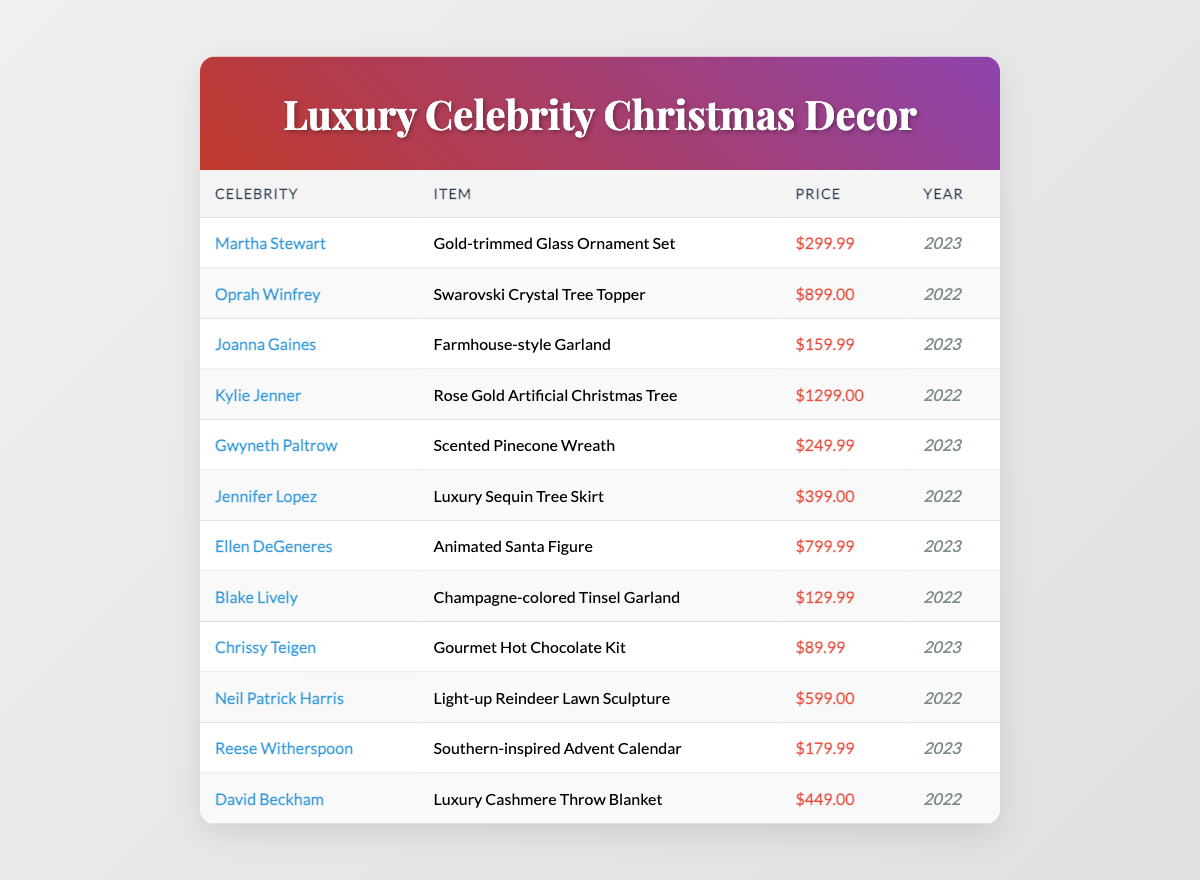What is the most expensive item in the list? To find the most expensive item, look at the price column and identify the highest value. The Rose Gold Artificial Christmas Tree by Kylie Jenner is priced at $1299.00, which is the highest among the items listed.
Answer: $1299.00 Which celebrity endorsed the Luxury Cashmere Throw Blanket? The table shows that the Luxury Cashmere Throw Blanket is endorsed by David Beckham. You can find his name in the celebrity column next to the corresponding item.
Answer: David Beckham How many items are there from the year 2023? Check the year column and count the occurrences of 2023. There are six items listed for the year 2023: Gold-trimmed Glass Ornament Set, Farmhouse-style Garland, Scented Pinecone Wreath, Animated Santa Figure, Gourmet Hot Chocolate Kit, and Southern-inspired Advent Calendar.
Answer: 6 What is the total price of all items endorsed by celebrities in 2022? To find the total price for items from 2022, sum up all the prices of items in that year: $899.00 (Oprah) + $1299.00 (Kylie) + $399.00 (Jennifer) + $599.00 (Neil) + $449.00 (David) = $3695.00.
Answer: $3695.00 Is the Scented Pinecone Wreath cheaper than the Luxury Sequin Tree Skirt? The price of the Scented Pinecone Wreath is $249.99, and the Luxury Sequin Tree Skirt is priced at $399.00. Since $249.99 is less than $399.00, the statement is true.
Answer: Yes Which celebrity has the item priced closest to $200? Look through the table to find prices around $200. The Southern-inspired Advent Calendar by Reese Witherspoon costs $179.99, which is the closest price to $200, as other items are either significantly higher or lower.
Answer: Reese Witherspoon What is the average price of all items listed in the table? To calculate the average price, sum all the prices: $299.99 + $899.00 + $159.99 + $1299.00 + $249.99 + $399.00 + $799.99 + $129.99 + $89.99 + $599.00 + $179.99 + $449.00 = $4825.00. There are 11 items, so the average is $4825.00 / 11 ≈ $438.64.
Answer: $438.64 How many items cost over $800? Check the table for any items priced above $800. The Swarovski Crystal Tree Topper ($899.00), Rose Gold Artificial Christmas Tree ($1299.00), and Animated Santa Figure ($799.99) are the relevant items. Since only the first two exceed $800, the total count is two.
Answer: 2 Which item was endorsed by Oprah Winfrey? The table lists the item endorsed by Oprah Winfrey as the Swarovski Crystal Tree Topper. You can directly refer to the celebrity column to find the corresponding item.
Answer: Swarovski Crystal Tree Topper What is the difference in price between the Animated Santa Figure and the Gold-trimmed Glass Ornament Set? The price of the Animated Santa Figure is $799.99 and the Gold-trimmed Glass Ornament Set is $299.99. To find the difference, subtract $299.99 from $799.99, which equals $500.00.
Answer: $500.00 Do any of the celebrities have more than one item listed? Review the table to check for any celebrities with multiple items. Each celebrity is shown only once in the table, meaning none have more than one item listed.
Answer: No 